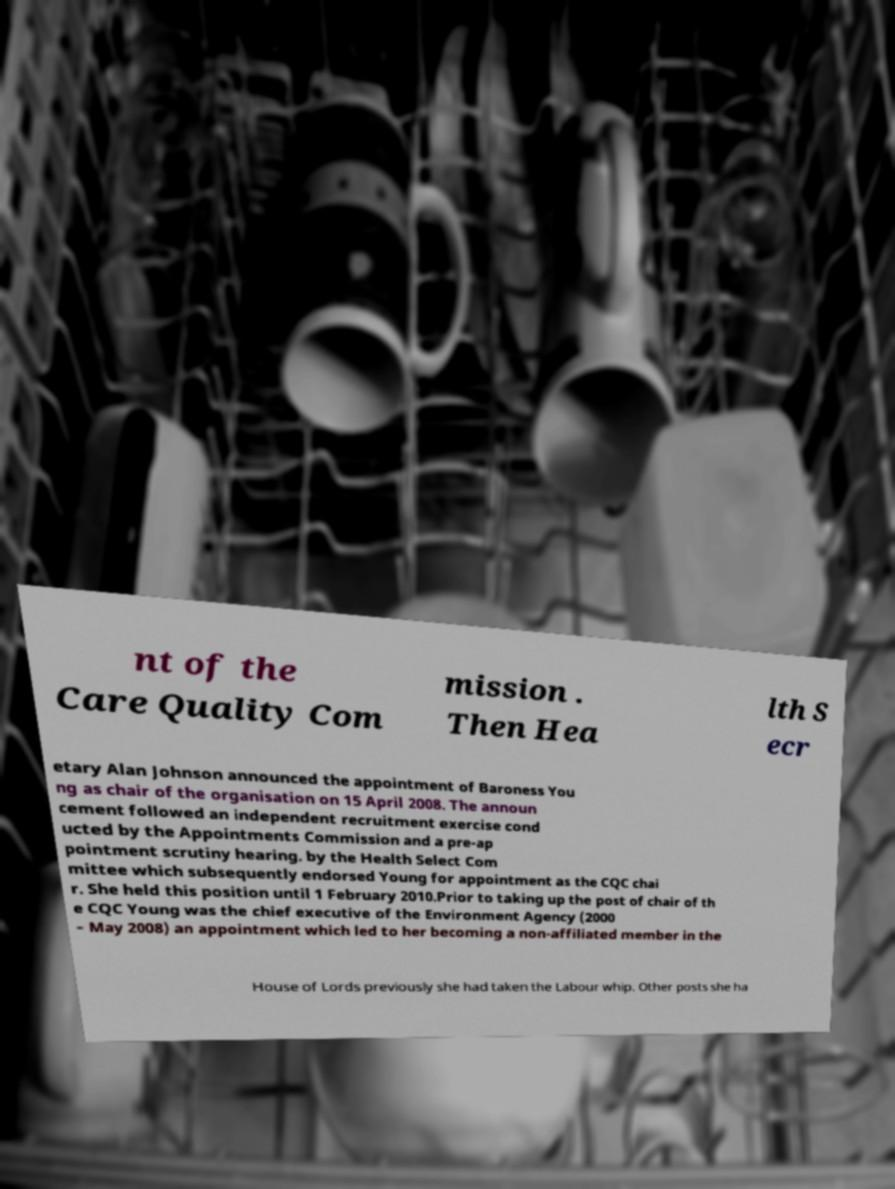Could you extract and type out the text from this image? nt of the Care Quality Com mission . Then Hea lth S ecr etary Alan Johnson announced the appointment of Baroness You ng as chair of the organisation on 15 April 2008. The announ cement followed an independent recruitment exercise cond ucted by the Appointments Commission and a pre-ap pointment scrutiny hearing. by the Health Select Com mittee which subsequently endorsed Young for appointment as the CQC chai r. She held this position until 1 February 2010.Prior to taking up the post of chair of th e CQC Young was the chief executive of the Environment Agency (2000 – May 2008) an appointment which led to her becoming a non-affiliated member in the House of Lords previously she had taken the Labour whip. Other posts she ha 